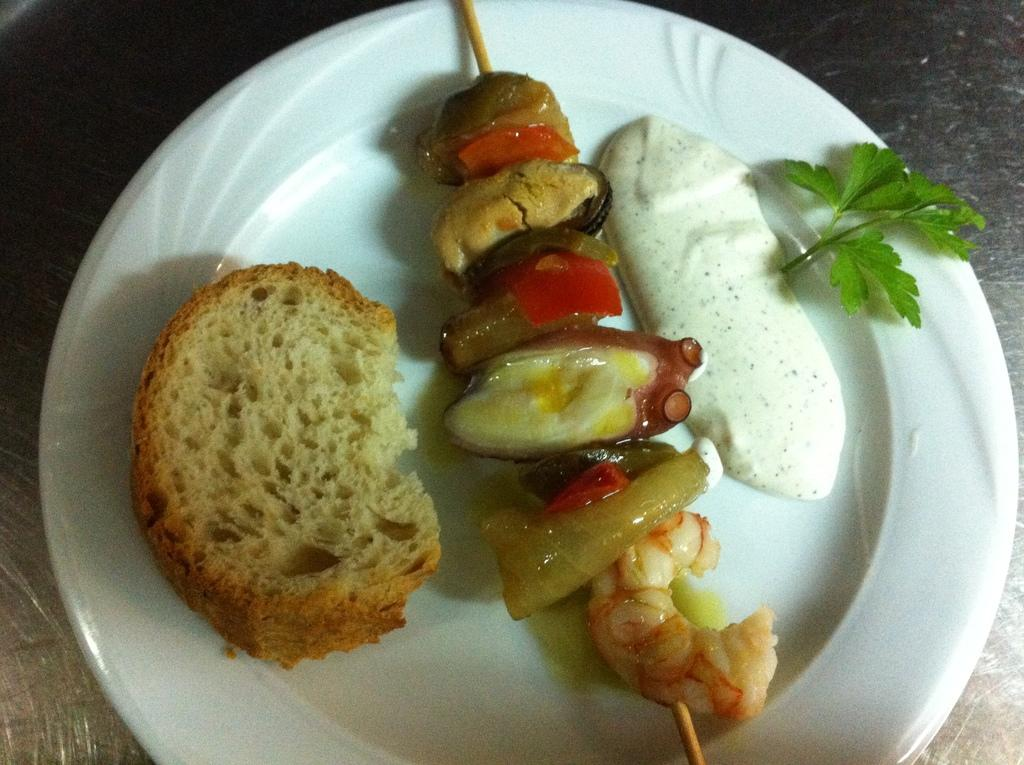What is the main object in the center of the image? There is a plate in the center of the image. What is on the plate? The plate contains food items. What type of spacecraft is visible in the image? There is no spacecraft present in the image; it only contains a plate with food items. What type of coach can be seen in the image? There is no coach present in the image; it only contains a plate with food items. 